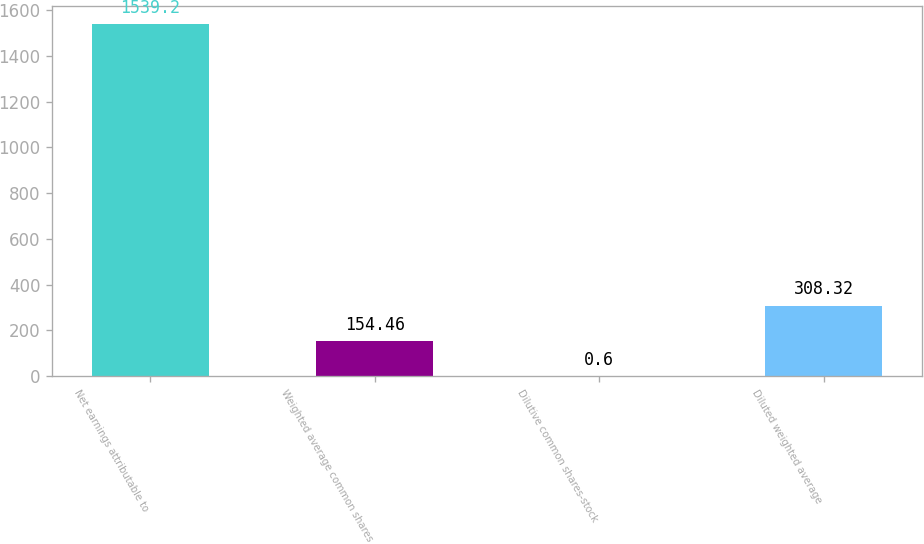Convert chart to OTSL. <chart><loc_0><loc_0><loc_500><loc_500><bar_chart><fcel>Net earnings attributable to<fcel>Weighted average common shares<fcel>Dilutive common shares-stock<fcel>Diluted weighted average<nl><fcel>1539.2<fcel>154.46<fcel>0.6<fcel>308.32<nl></chart> 